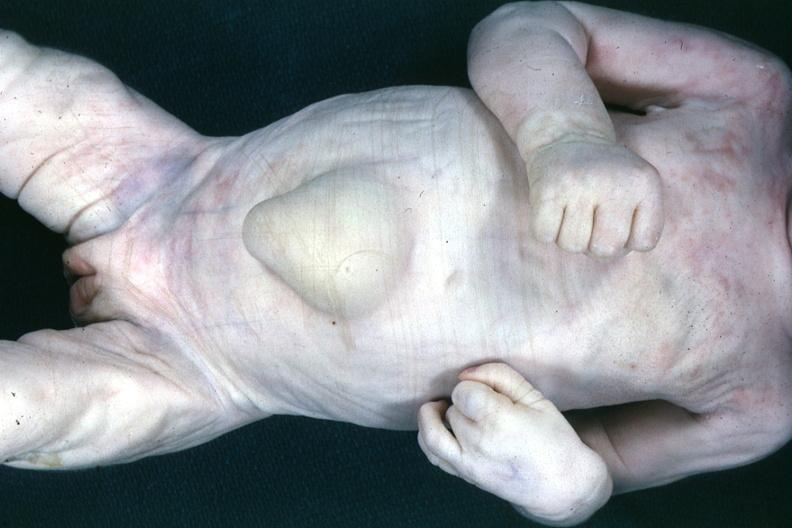does this image show good example of large umbilical hernia?
Answer the question using a single word or phrase. Yes 